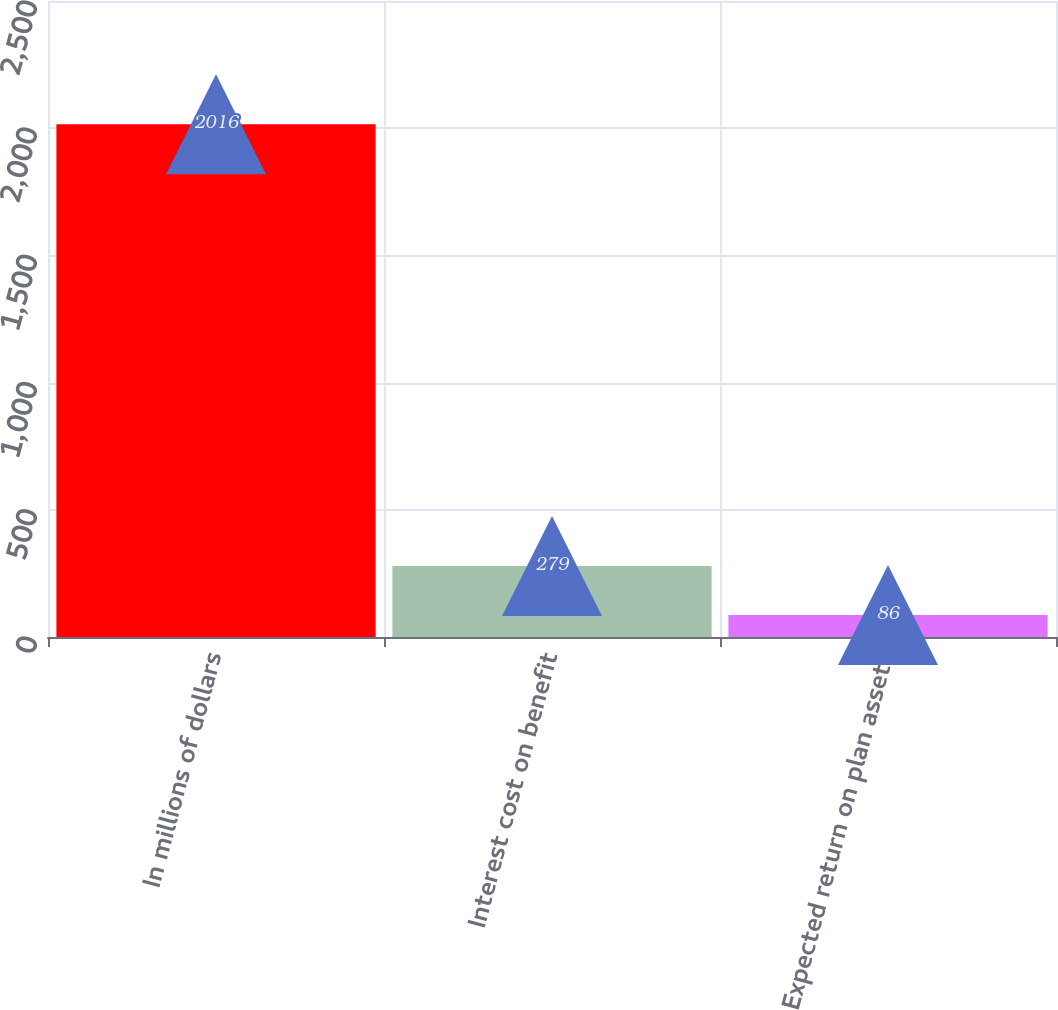<chart> <loc_0><loc_0><loc_500><loc_500><bar_chart><fcel>In millions of dollars<fcel>Interest cost on benefit<fcel>Expected return on plan assets<nl><fcel>2016<fcel>279<fcel>86<nl></chart> 